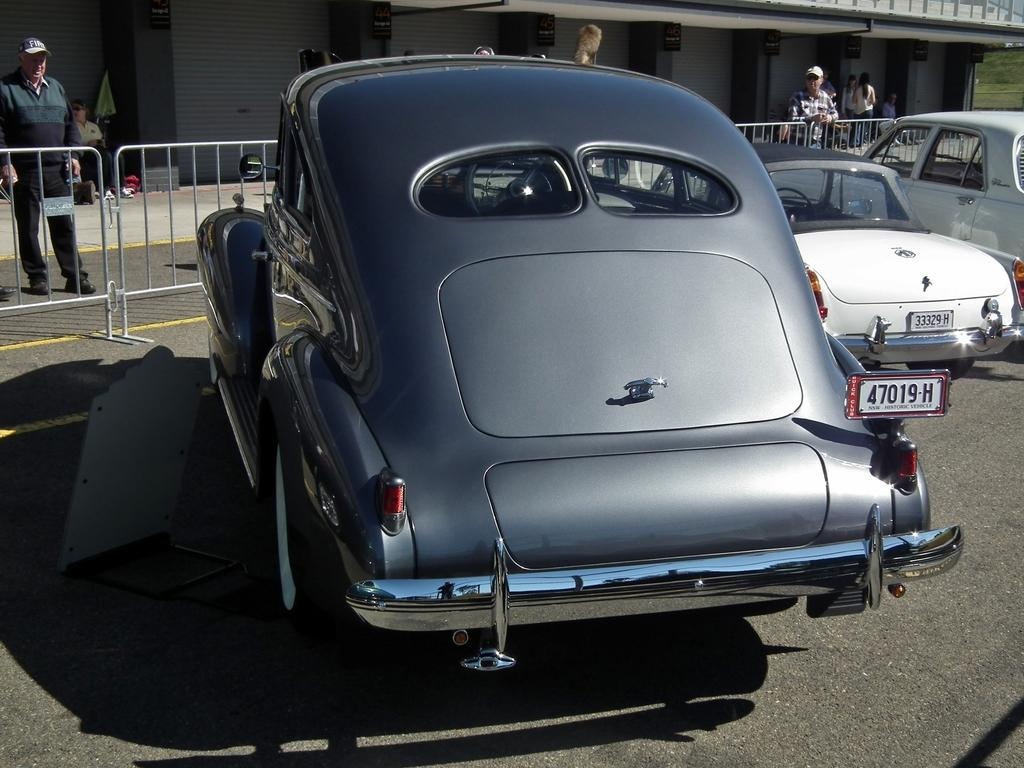What types of objects are present in the image? There are vehicles, a road, fencing, people, a building, and grass on the ground visible in the image. Can you describe the setting of the image? The image features a road, fencing, a building, and grass on the ground, suggesting an outdoor scene. How many people are present in the image? There are people in the image, but the exact number is not specified. What is the ground surface like in the image? The ground is visible in the image, and there is grass on the ground. What type of clock is visible on the road in the image? There is no clock present on the road in the image. Can you tell me how many times the people in the image have copied the same action? There is no information about the people's actions or repetitions in the image. 